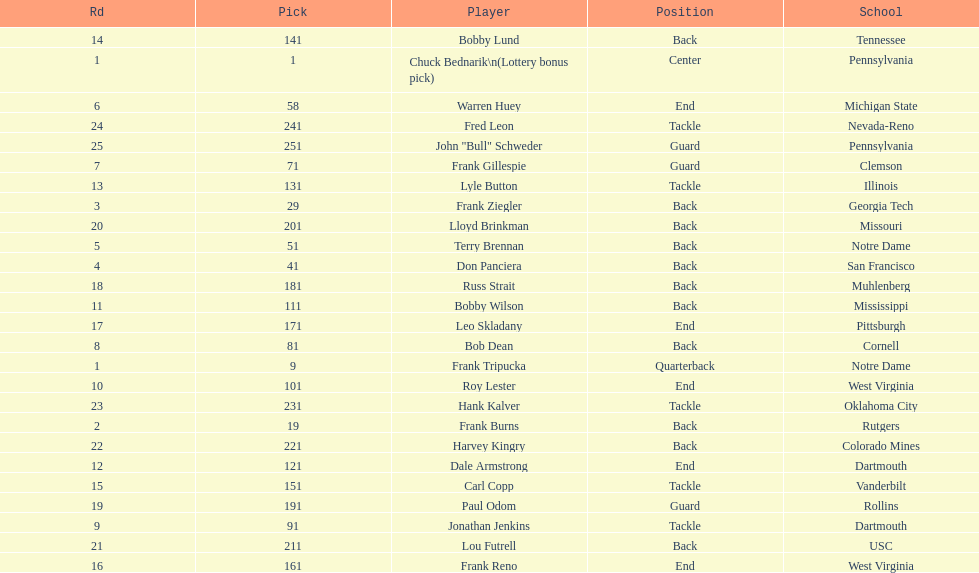Highest rd number? 25. 